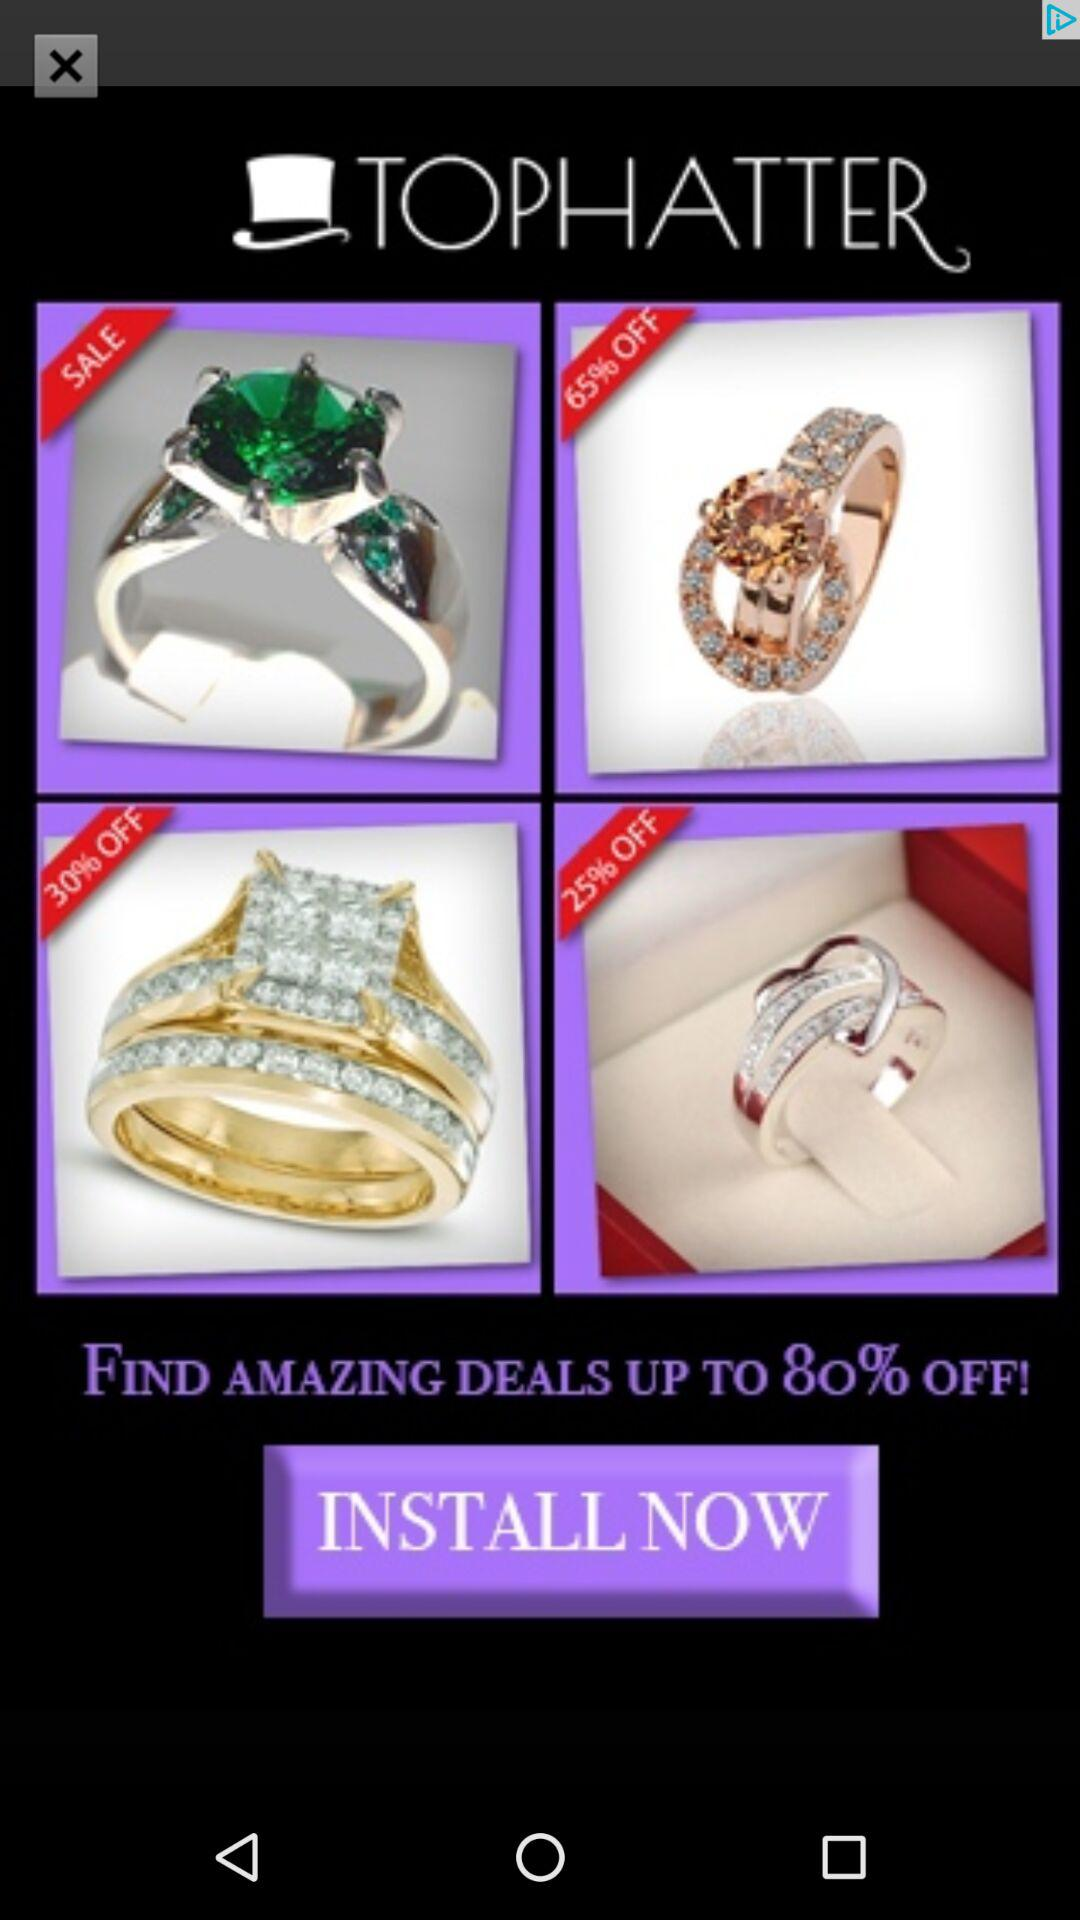How many items are on sale with a discount of 30% or more?
Answer the question using a single word or phrase. 2 